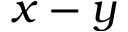Convert formula to latex. <formula><loc_0><loc_0><loc_500><loc_500>x - y</formula> 